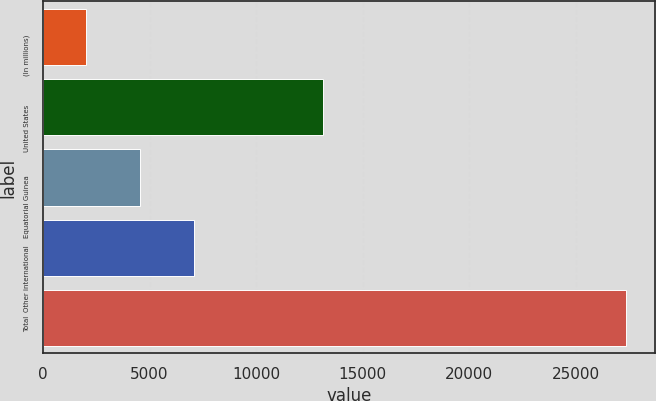<chart> <loc_0><loc_0><loc_500><loc_500><bar_chart><fcel>(In millions)<fcel>United States<fcel>Equatorial Guinea<fcel>Other international<fcel>Total<nl><fcel>2007<fcel>13133<fcel>4541.1<fcel>7075.2<fcel>27348<nl></chart> 